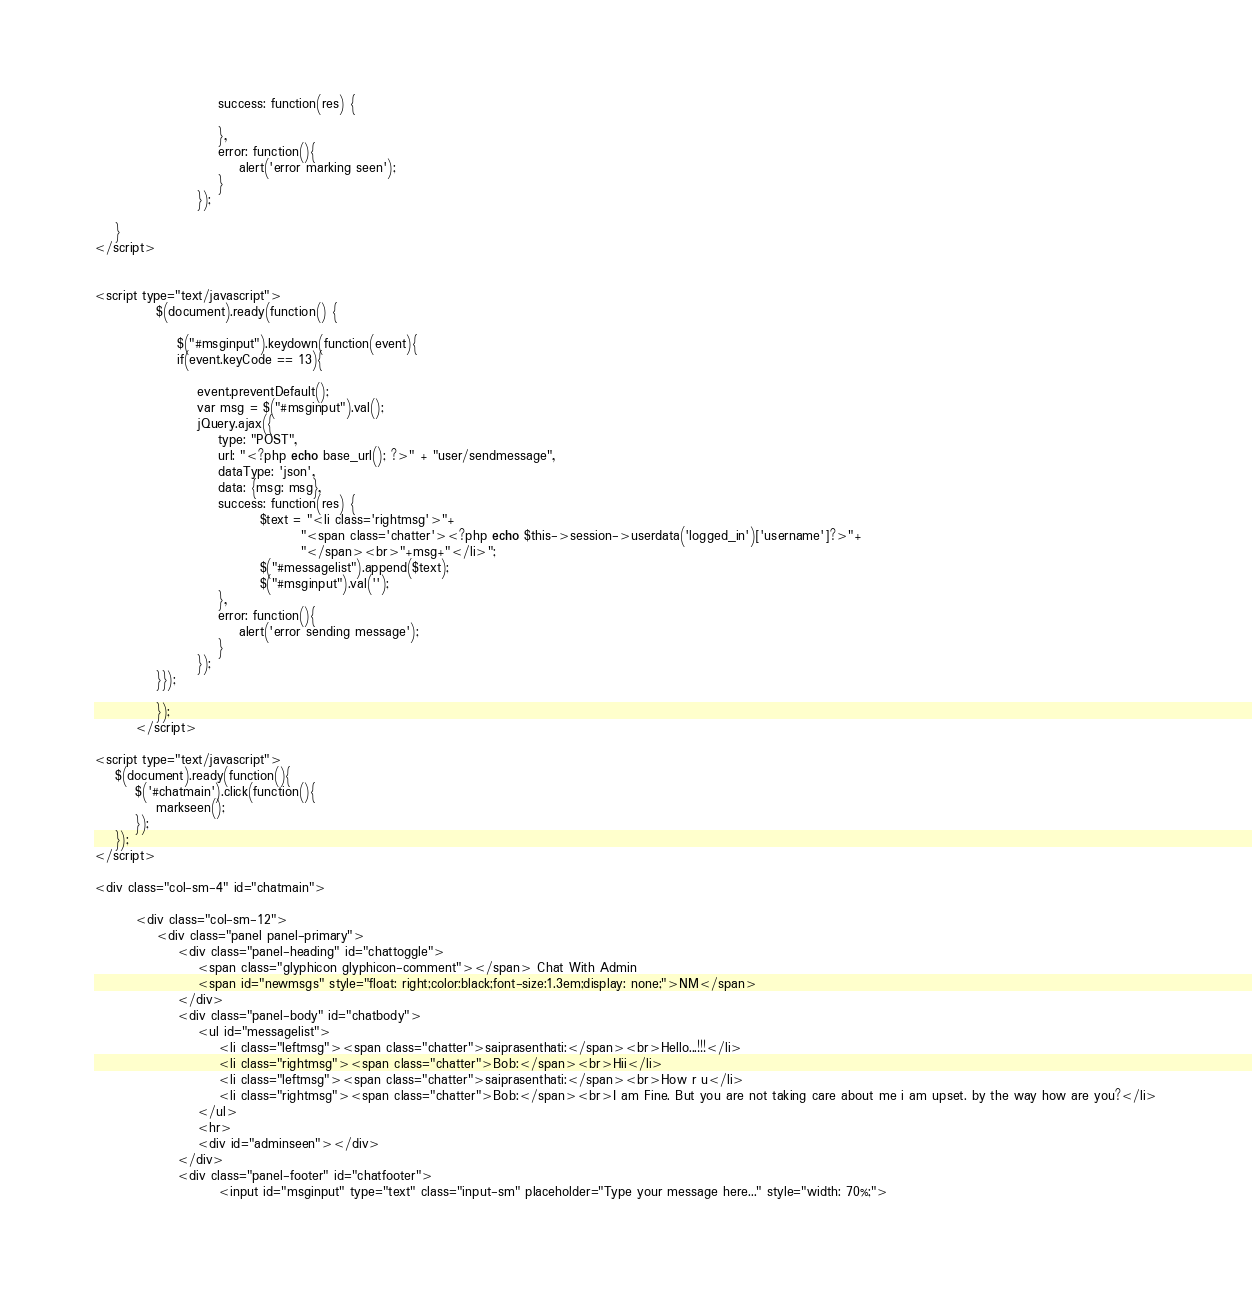Convert code to text. <code><loc_0><loc_0><loc_500><loc_500><_PHP_>                        success: function(res) {
                            
                        },
                        error: function(){
                            alert('error marking seen');
                        }
                    });

    }
</script>
	   

<script type="text/javascript">
            $(document).ready(function() {

                $("#msginput").keydown(function(event){
                if(event.keyCode == 13){

                    event.preventDefault();
                    var msg = $("#msginput").val();
                    jQuery.ajax({
                        type: "POST",
                        url: "<?php echo base_url(); ?>" + "user/sendmessage",
                        dataType: 'json',
                        data: {msg: msg},
                        success: function(res) {
                                $text = "<li class='rightmsg'>"+
                                		"<span class='chatter'><?php echo $this->session->userdata('logged_in')['username']?>"+
                                		"</span><br>"+msg+"</li>";
                                $("#messagelist").append($text);
                                $("#msginput").val('');        
                        },
                        error: function(){
                        	alert('error sending message');
                        }
                    });
            }});

            });
        </script>

<script type="text/javascript">
    $(document).ready(function(){
        $('#chatmain').click(function(){
            markseen();
        });
    });
</script>

<div class="col-sm-4" id="chatmain">
	
        <div class="col-sm-12">
            <div class="panel panel-primary">
                <div class="panel-heading" id="chattoggle">
                    <span class="glyphicon glyphicon-comment"></span> Chat With Admin
                    <span id="newmsgs" style="float: right;color:black;font-size:1.3em;display: none;">NM</span>
                </div>
                <div class="panel-body" id="chatbody">
                    <ul id="messagelist">
                    	<li class="leftmsg"><span class="chatter">saiprasenthati:</span><br>Hello...!!!</li>
                    	<li class="rightmsg"><span class="chatter">Bob:</span><br>Hii</li>
                    	<li class="leftmsg"><span class="chatter">saiprasenthati:</span><br>How r u</li>
                    	<li class="rightmsg"><span class="chatter">Bob:</span><br>I am Fine. But you are not taking care about me i am upset. by the way how are you?</li>
                    </ul>
                    <hr>
                    <div id="adminseen"></div>
                </div>
                <div class="panel-footer" id="chatfooter">
                        <input id="msginput" type="text" class="input-sm" placeholder="Type your message here..." style="width: 70%;"></code> 